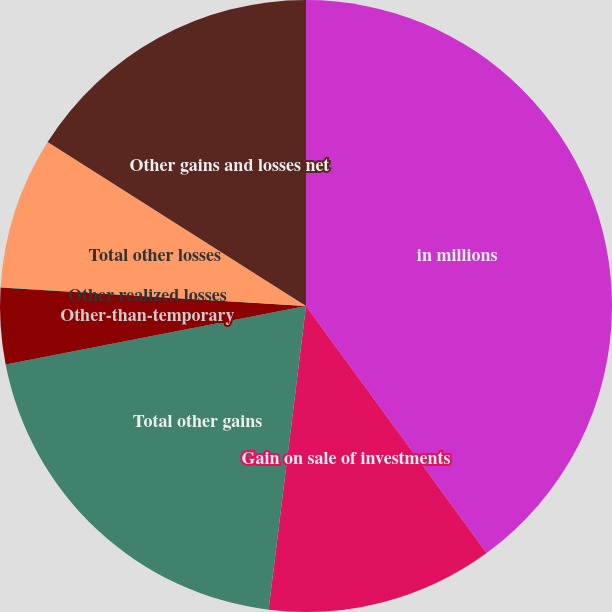<chart> <loc_0><loc_0><loc_500><loc_500><pie_chart><fcel>in millions<fcel>Gain on sale of investments<fcel>Total other gains<fcel>Other-than-temporary<fcel>Other realized losses<fcel>Total other losses<fcel>Other gains and losses net<nl><fcel>39.95%<fcel>12.0%<fcel>19.99%<fcel>4.02%<fcel>0.03%<fcel>8.01%<fcel>16.0%<nl></chart> 